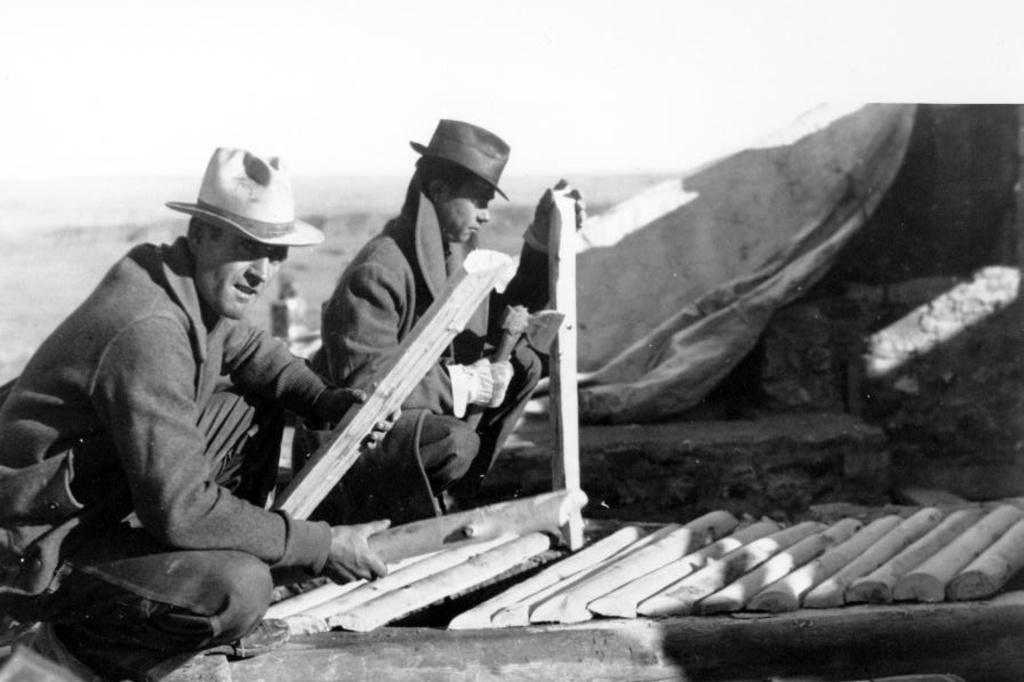Could you give a brief overview of what you see in this image? This is a black and white picture, in the image we can see two persons holding the objects, in front of them, we can see some wooden sticks and behind the persons there are mountains and in the background we can see the sky. 